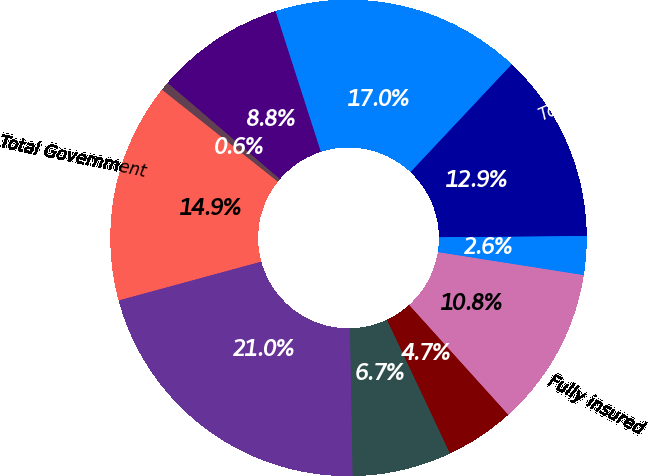Convert chart. <chart><loc_0><loc_0><loc_500><loc_500><pie_chart><fcel>Fully insured<fcel>Specialty<fcel>Total Commercial<fcel>Medicare Advantage<fcel>TRICARE<fcel>Medicaid<fcel>Total Government<fcel>Total<fcel>Commercial<fcel>Government<nl><fcel>10.82%<fcel>2.63%<fcel>12.86%<fcel>16.96%<fcel>8.77%<fcel>0.59%<fcel>14.91%<fcel>21.05%<fcel>6.73%<fcel>4.68%<nl></chart> 